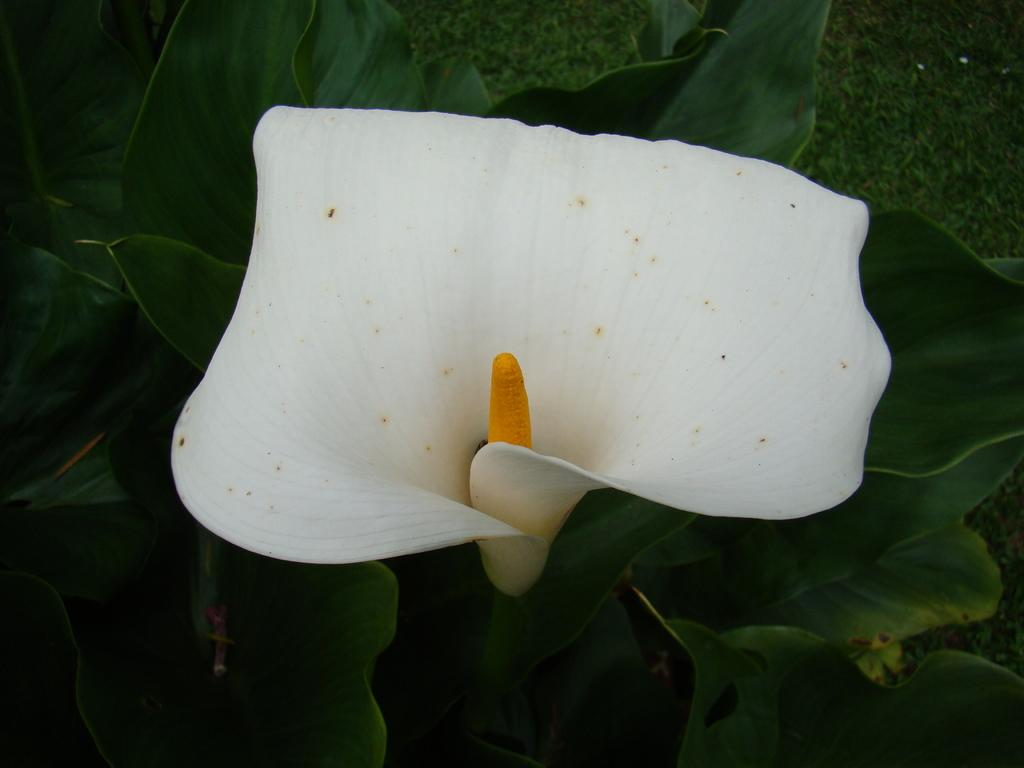What is the main subject of the image? There is a flower in the image. What can be seen behind the flower? There are leaves behind the flower in the image. What type of songs can be heard coming from the flower in the image? There is no indication in the image that the flower is producing any sounds, so it's not possible to determine what, if any, songs might be heard. 